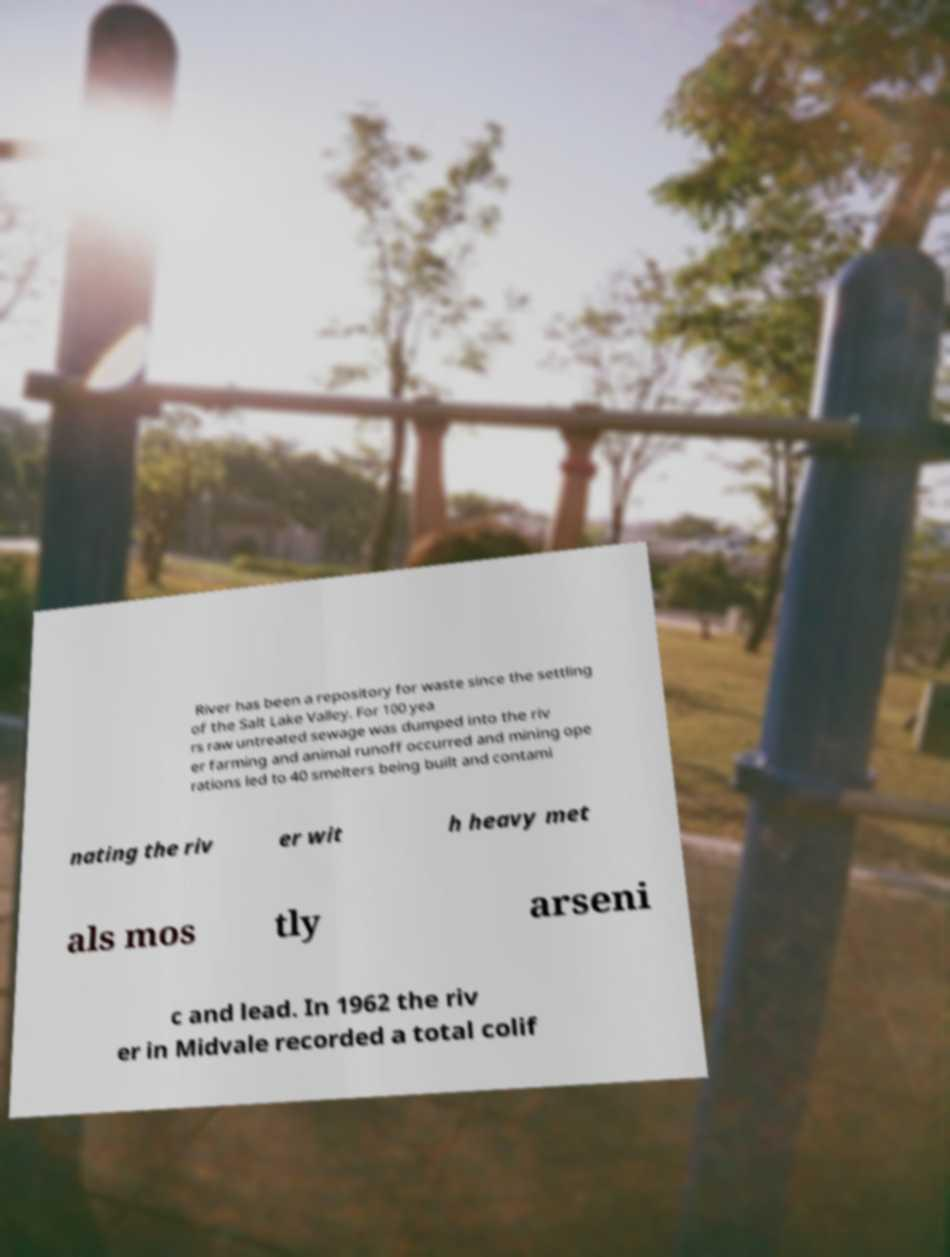Please identify and transcribe the text found in this image. River has been a repository for waste since the settling of the Salt Lake Valley. For 100 yea rs raw untreated sewage was dumped into the riv er farming and animal runoff occurred and mining ope rations led to 40 smelters being built and contami nating the riv er wit h heavy met als mos tly arseni c and lead. In 1962 the riv er in Midvale recorded a total colif 